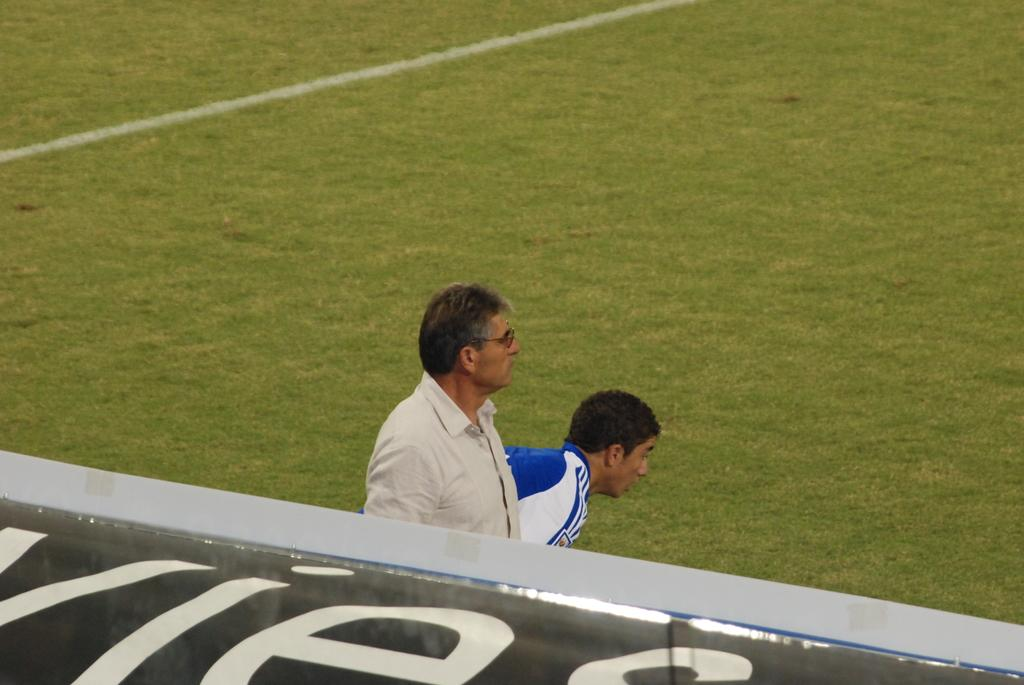How many people are in the image? There are two persons in the center of the image. What is the board with text used for in the image? The board with text is in the center of the image, but the purpose is not clear from the facts provided. What is one distinguishing feature of one of the persons? One person is wearing glasses. What type of natural environment is visible in the background of the image? There is grass visible in the background of the image. Where is the shelf located in the image? There is no shelf present in the image. What type of hook is used to hang the glasses on the person's face? The person is not wearing a hook to hold their glasses; they are simply resting on their nose and ears. 